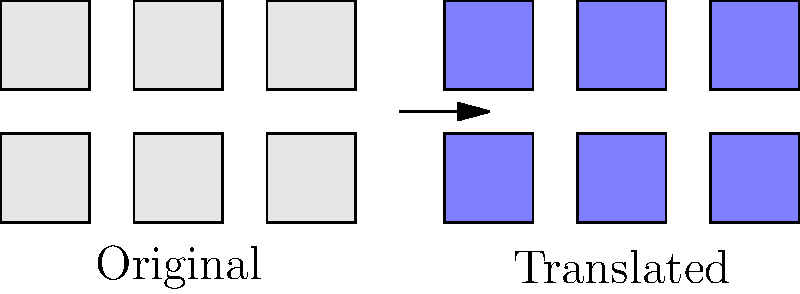The seating arrangement diagram of the Ilkeston Flyer bus has been translated as shown above. What is the translation vector that moves the original diagram to its new position? To find the translation vector, we need to follow these steps:

1. Identify a reference point in the original diagram and its corresponding point in the translated diagram.
   Let's use the bottom-left corner of the leftmost seat.

2. Original point: $(0,0)$
   Translated point: $(5,0)$

3. Calculate the displacement:
   $x$ displacement = $5 - 0 = 5$
   $y$ displacement = $0 - 0 = 0$

4. The translation vector is the displacement from the original point to the translated point.
   In this case, it's $\langle 5, 0 \rangle$.

5. In vector notation, we write this as $\vec{v} = \langle 5, 0 \rangle$ or $(5,0)$.

Therefore, the translation vector that moves the original diagram to its new position is $\langle 5, 0 \rangle$ or $(5,0)$.
Answer: $\langle 5, 0 \rangle$ 